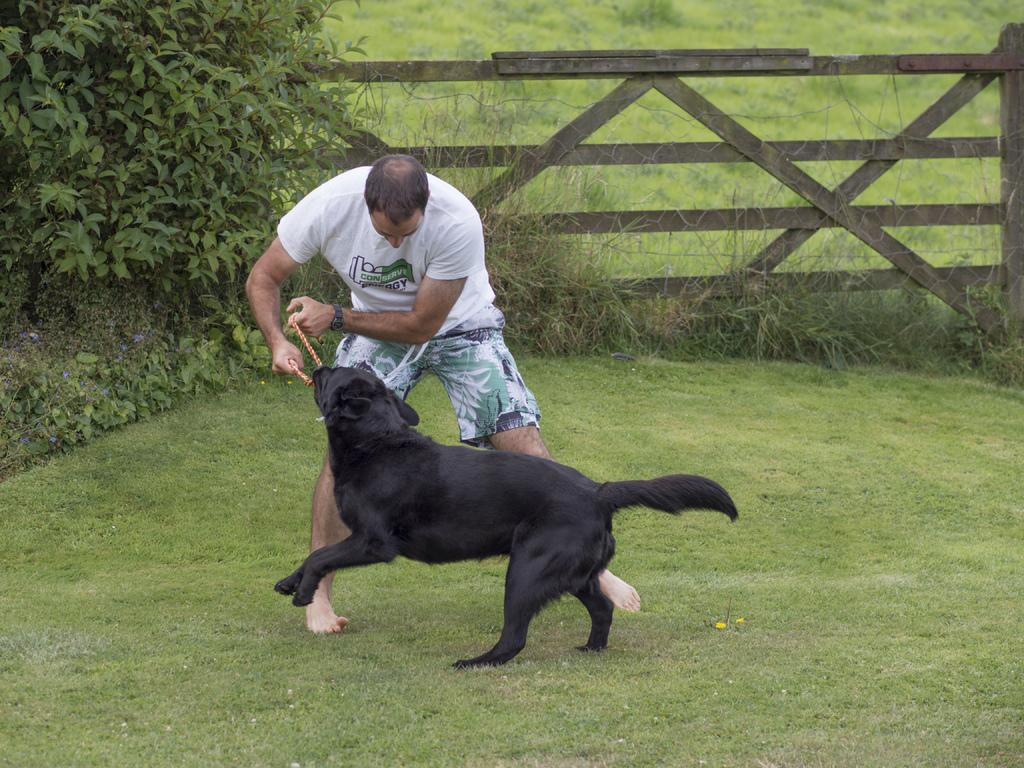Who or what is in the center of the image? There is a man and a dog in the center of the image. What is the setting of the image? The man and dog are on the grass. What can be seen on the left side of the image? There is a tree on the left side of the image. What is visible in the background of the image? There is fencing and grass in the background of the image. What type of bulb can be seen lighting up the area in the image? There is no bulb present in the image; it is an outdoor scene with natural lighting. Are there any fairies visible in the image? There are no fairies present in the image; it features a man and a dog on the grass. 